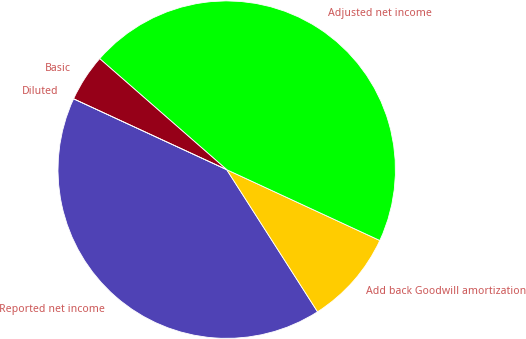<chart> <loc_0><loc_0><loc_500><loc_500><pie_chart><fcel>Reported net income<fcel>Add back Goodwill amortization<fcel>Adjusted net income<fcel>Basic<fcel>Diluted<nl><fcel>40.95%<fcel>9.05%<fcel>45.47%<fcel>4.53%<fcel>0.0%<nl></chart> 